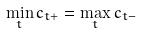Convert formula to latex. <formula><loc_0><loc_0><loc_500><loc_500>\min _ { t } c _ { t + } = \max _ { t } c _ { t - }</formula> 